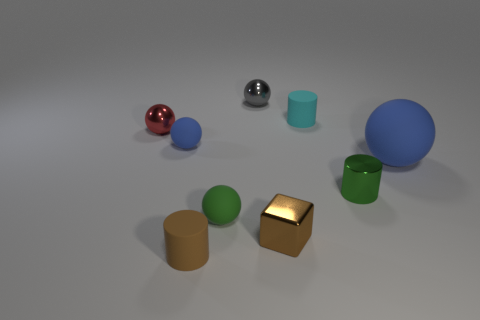How many purple objects are either blocks or small cylinders?
Ensure brevity in your answer.  0. Are there any brown cylinders that have the same size as the red ball?
Your answer should be very brief. Yes. What is the material of the block that is the same size as the red ball?
Ensure brevity in your answer.  Metal. Do the matte cylinder that is to the left of the cube and the shiny ball that is to the right of the red shiny sphere have the same size?
Make the answer very short. Yes. How many objects are either tiny brown things or objects behind the green ball?
Make the answer very short. 8. Are there any tiny blue matte things that have the same shape as the small red metal thing?
Ensure brevity in your answer.  Yes. There is a brown metallic cube that is in front of the blue thing that is on the left side of the metallic block; what size is it?
Keep it short and to the point. Small. How many metallic objects are either small gray spheres or large things?
Ensure brevity in your answer.  1. What number of small things are there?
Provide a succinct answer. 8. Does the blue thing that is right of the tiny brown metal block have the same material as the small object behind the small cyan cylinder?
Offer a terse response. No. 